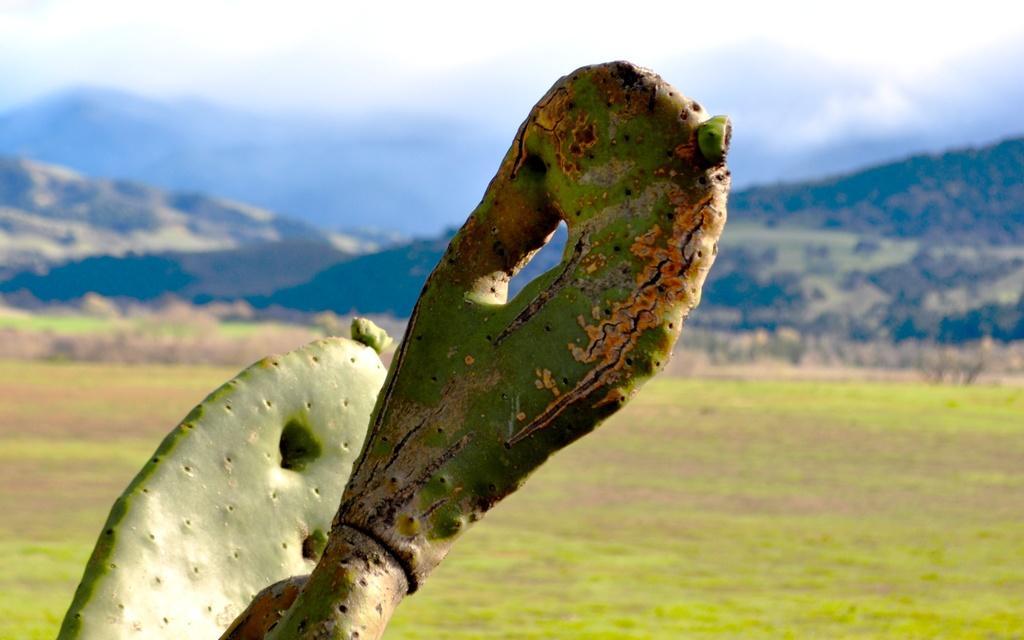Describe this image in one or two sentences. In this picture we can see a cactus plant. Some grass is visible on the ground. We can see a few mountains in the background. Sky is cloudy. 